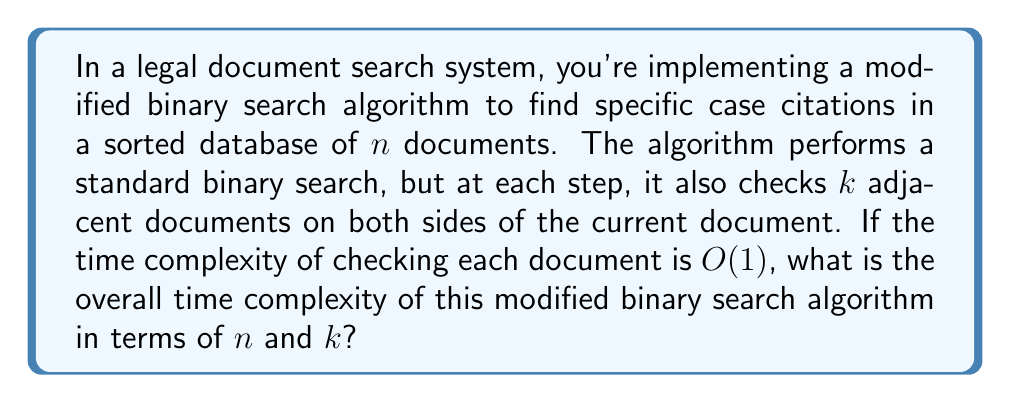Solve this math problem. To analyze the time complexity of this modified binary search algorithm, let's break it down step-by-step:

1. Standard binary search:
   The time complexity of a standard binary search is $O(\log n)$, where $n$ is the number of documents in the database.

2. Additional checks at each step:
   At each step of the binary search, the algorithm checks $k$ adjacent documents on both sides. This means $2k + 1$ documents are checked at each step (including the current document).

3. Number of steps:
   The binary search makes at most $\log_2 n$ steps to narrow down the search range.

4. Total number of document checks:
   At each step, $2k + 1$ documents are checked.
   Total checks = $(\text{number of steps}) \times (\text{checks per step})$
   $= \log_2 n \times (2k + 1)$

5. Time complexity of each check:
   Given that checking each document takes $O(1)$ time.

6. Overall time complexity:
   $$T(n, k) = O(\log_2 n \times (2k + 1))$$
   $$= O((2k + 1) \log n)$$
   $$= O(k \log n)$$

The last step is possible because we can drop the constant factor and the +1 term inside the parentheses, as they don't affect the asymptotic growth rate.

Therefore, the overall time complexity of this modified binary search algorithm is $O(k \log n)$.
Answer: $O(k \log n)$ 